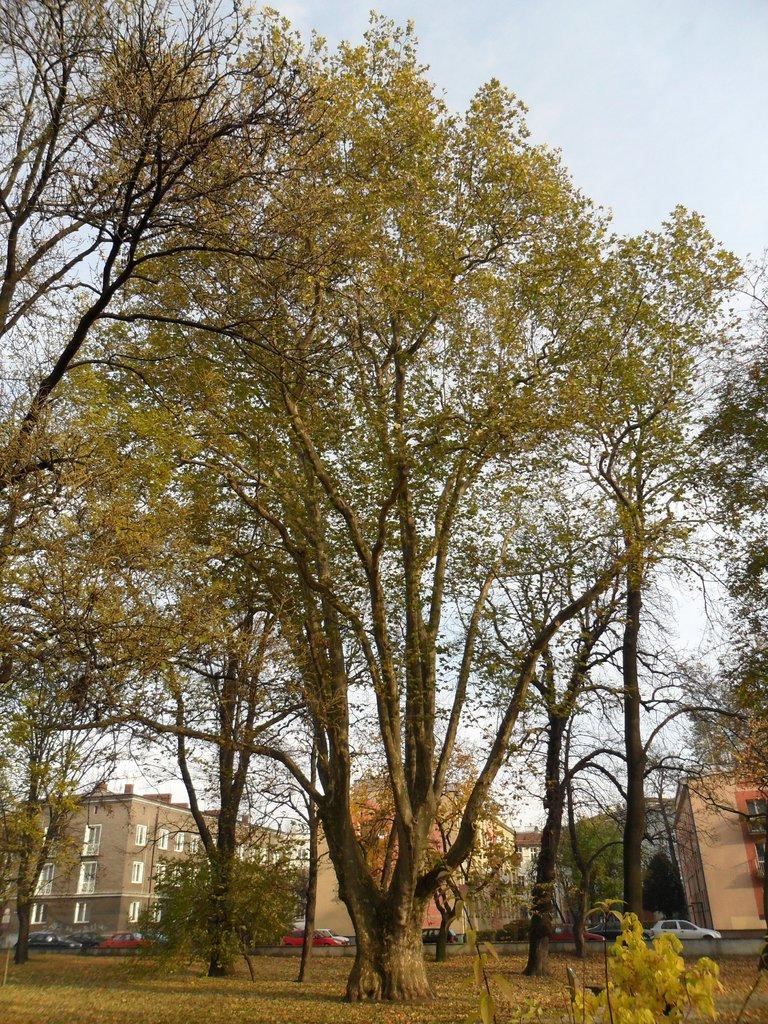How would you summarize this image in a sentence or two? In this image we can see buildings, motor vehicles on the road, plants, trees and sky with clouds in the background. 